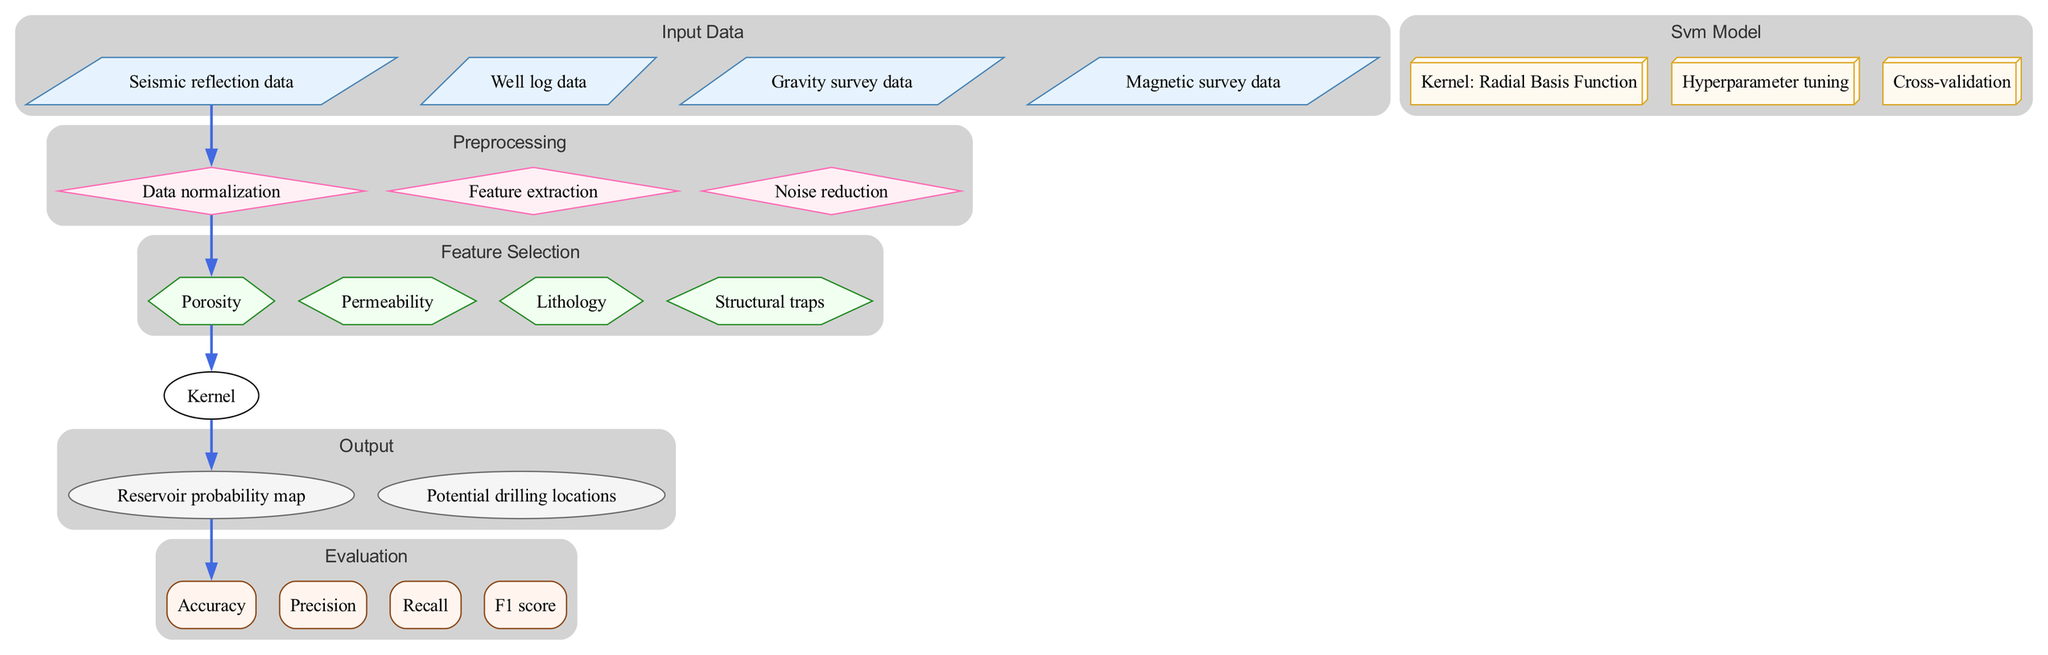What are the inputs to this model? The model has four inputs: Seismic reflection data, Well log data, Gravity survey data, and Magnetic survey data. These are listed under the "input_data" section of the diagram.
Answer: Seismic reflection data, Well log data, Gravity survey data, Magnetic survey data What processing is performed on the input data? The input data undergoes three preprocessing steps: Data normalization, Feature extraction, and Noise reduction. This is indicated by the "preprocessing" section linked to the inputs.
Answer: Data normalization, Feature extraction, Noise reduction How many features are selected for the SVM model? The "feature_selection" section indicates that four features are selected: Porosity, Permeability, Lithology, and Structural traps. Hence, the total count is four.
Answer: Four What is the kernel used in the SVM model? According to the "svm_model" section, the kernel employed in this model is the Radial Basis Function. This is a direct reference in the diagram.
Answer: Radial Basis Function What is the first output of this model? The model produces two outputs as seen in the "output" section, where the first is the Reservoir probability map. This follows the flow from the SVM model.
Answer: Reservoir probability map What evaluation metrics are used? The "evaluation" section lists four metrics: Accuracy, Precision, Recall, and F1 score. These metrics are used to assess the model's performance.
Answer: Accuracy, Precision, Recall, F1 score How does input data connect to preprocessing? The diagram shows a directed edge connecting the "input_data" node to the "preprocessing" node, indicating that input data is processed first before feature selection.
Answer: Directed edge What is the role of hyperparameter tuning in this model? Hyperparameter tuning is part of the "svm_model" section, where it is a process to optimize SVM parameters, improving model performance before generating outputs.
Answer: Optimize SVM parameters Which component comes directly after feature selection in the diagram? The "svm_model" component follows the "feature_selection" section, indicating that after selecting features, the model is built and applied.
Answer: SVM model 